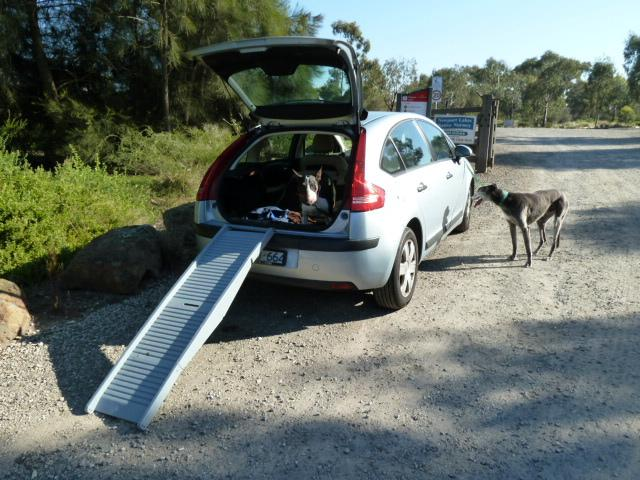What uses the ramp on the back of the car? dog 